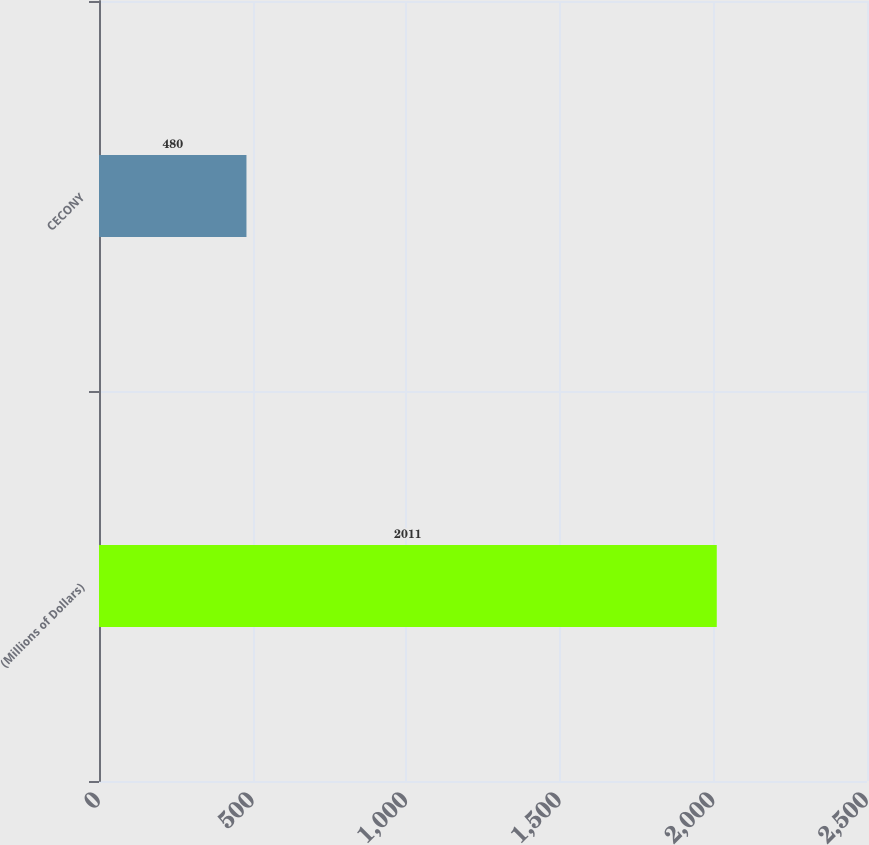Convert chart. <chart><loc_0><loc_0><loc_500><loc_500><bar_chart><fcel>(Millions of Dollars)<fcel>CECONY<nl><fcel>2011<fcel>480<nl></chart> 